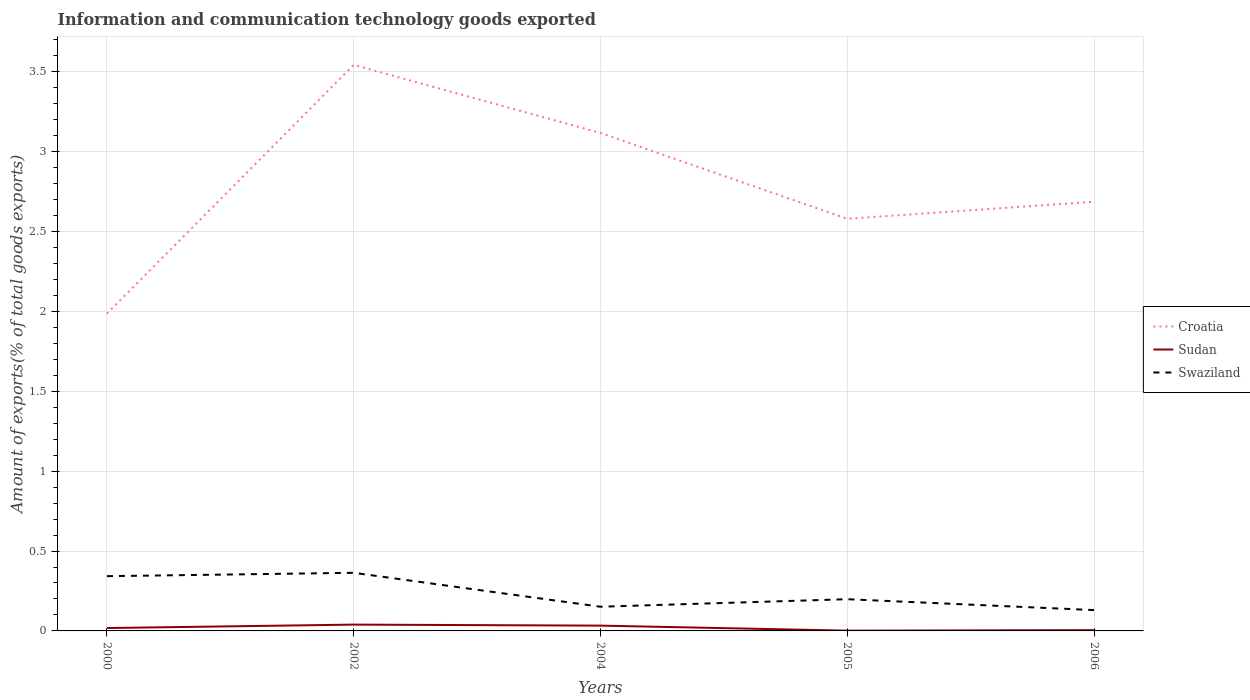How many different coloured lines are there?
Make the answer very short. 3. Is the number of lines equal to the number of legend labels?
Keep it short and to the point. Yes. Across all years, what is the maximum amount of goods exported in Swaziland?
Your answer should be compact. 0.13. In which year was the amount of goods exported in Swaziland maximum?
Offer a terse response. 2006. What is the total amount of goods exported in Swaziland in the graph?
Your answer should be compact. 0.07. What is the difference between the highest and the second highest amount of goods exported in Sudan?
Ensure brevity in your answer.  0.04. What is the difference between the highest and the lowest amount of goods exported in Sudan?
Provide a short and direct response. 2. Is the amount of goods exported in Swaziland strictly greater than the amount of goods exported in Sudan over the years?
Offer a terse response. No. How many lines are there?
Offer a very short reply. 3. Are the values on the major ticks of Y-axis written in scientific E-notation?
Offer a very short reply. No. Does the graph contain any zero values?
Ensure brevity in your answer.  No. Where does the legend appear in the graph?
Offer a very short reply. Center right. How many legend labels are there?
Offer a terse response. 3. How are the legend labels stacked?
Your answer should be very brief. Vertical. What is the title of the graph?
Make the answer very short. Information and communication technology goods exported. What is the label or title of the X-axis?
Make the answer very short. Years. What is the label or title of the Y-axis?
Ensure brevity in your answer.  Amount of exports(% of total goods exports). What is the Amount of exports(% of total goods exports) in Croatia in 2000?
Your answer should be compact. 1.99. What is the Amount of exports(% of total goods exports) in Sudan in 2000?
Offer a very short reply. 0.02. What is the Amount of exports(% of total goods exports) in Swaziland in 2000?
Give a very brief answer. 0.34. What is the Amount of exports(% of total goods exports) of Croatia in 2002?
Your response must be concise. 3.54. What is the Amount of exports(% of total goods exports) of Sudan in 2002?
Make the answer very short. 0.04. What is the Amount of exports(% of total goods exports) of Swaziland in 2002?
Your answer should be very brief. 0.36. What is the Amount of exports(% of total goods exports) in Croatia in 2004?
Offer a terse response. 3.12. What is the Amount of exports(% of total goods exports) of Sudan in 2004?
Give a very brief answer. 0.03. What is the Amount of exports(% of total goods exports) in Swaziland in 2004?
Offer a terse response. 0.15. What is the Amount of exports(% of total goods exports) in Croatia in 2005?
Your response must be concise. 2.58. What is the Amount of exports(% of total goods exports) in Sudan in 2005?
Ensure brevity in your answer.  0. What is the Amount of exports(% of total goods exports) of Swaziland in 2005?
Keep it short and to the point. 0.2. What is the Amount of exports(% of total goods exports) in Croatia in 2006?
Make the answer very short. 2.69. What is the Amount of exports(% of total goods exports) of Sudan in 2006?
Ensure brevity in your answer.  0. What is the Amount of exports(% of total goods exports) of Swaziland in 2006?
Offer a very short reply. 0.13. Across all years, what is the maximum Amount of exports(% of total goods exports) in Croatia?
Your answer should be compact. 3.54. Across all years, what is the maximum Amount of exports(% of total goods exports) of Sudan?
Give a very brief answer. 0.04. Across all years, what is the maximum Amount of exports(% of total goods exports) in Swaziland?
Your response must be concise. 0.36. Across all years, what is the minimum Amount of exports(% of total goods exports) of Croatia?
Your answer should be very brief. 1.99. Across all years, what is the minimum Amount of exports(% of total goods exports) of Sudan?
Your response must be concise. 0. Across all years, what is the minimum Amount of exports(% of total goods exports) of Swaziland?
Provide a short and direct response. 0.13. What is the total Amount of exports(% of total goods exports) in Croatia in the graph?
Ensure brevity in your answer.  13.91. What is the total Amount of exports(% of total goods exports) of Sudan in the graph?
Provide a succinct answer. 0.1. What is the total Amount of exports(% of total goods exports) in Swaziland in the graph?
Your answer should be compact. 1.19. What is the difference between the Amount of exports(% of total goods exports) in Croatia in 2000 and that in 2002?
Your answer should be compact. -1.56. What is the difference between the Amount of exports(% of total goods exports) in Sudan in 2000 and that in 2002?
Give a very brief answer. -0.02. What is the difference between the Amount of exports(% of total goods exports) of Swaziland in 2000 and that in 2002?
Your response must be concise. -0.02. What is the difference between the Amount of exports(% of total goods exports) in Croatia in 2000 and that in 2004?
Your answer should be very brief. -1.13. What is the difference between the Amount of exports(% of total goods exports) of Sudan in 2000 and that in 2004?
Your answer should be very brief. -0.02. What is the difference between the Amount of exports(% of total goods exports) of Swaziland in 2000 and that in 2004?
Make the answer very short. 0.19. What is the difference between the Amount of exports(% of total goods exports) in Croatia in 2000 and that in 2005?
Keep it short and to the point. -0.59. What is the difference between the Amount of exports(% of total goods exports) in Sudan in 2000 and that in 2005?
Offer a very short reply. 0.02. What is the difference between the Amount of exports(% of total goods exports) of Swaziland in 2000 and that in 2005?
Give a very brief answer. 0.14. What is the difference between the Amount of exports(% of total goods exports) in Croatia in 2000 and that in 2006?
Keep it short and to the point. -0.7. What is the difference between the Amount of exports(% of total goods exports) in Sudan in 2000 and that in 2006?
Keep it short and to the point. 0.01. What is the difference between the Amount of exports(% of total goods exports) of Swaziland in 2000 and that in 2006?
Make the answer very short. 0.21. What is the difference between the Amount of exports(% of total goods exports) in Croatia in 2002 and that in 2004?
Make the answer very short. 0.43. What is the difference between the Amount of exports(% of total goods exports) of Sudan in 2002 and that in 2004?
Give a very brief answer. 0.01. What is the difference between the Amount of exports(% of total goods exports) of Swaziland in 2002 and that in 2004?
Your answer should be very brief. 0.21. What is the difference between the Amount of exports(% of total goods exports) of Croatia in 2002 and that in 2005?
Your answer should be compact. 0.96. What is the difference between the Amount of exports(% of total goods exports) of Sudan in 2002 and that in 2005?
Your answer should be compact. 0.04. What is the difference between the Amount of exports(% of total goods exports) of Swaziland in 2002 and that in 2005?
Your response must be concise. 0.17. What is the difference between the Amount of exports(% of total goods exports) of Croatia in 2002 and that in 2006?
Your answer should be very brief. 0.86. What is the difference between the Amount of exports(% of total goods exports) in Sudan in 2002 and that in 2006?
Your answer should be compact. 0.03. What is the difference between the Amount of exports(% of total goods exports) of Swaziland in 2002 and that in 2006?
Make the answer very short. 0.23. What is the difference between the Amount of exports(% of total goods exports) in Croatia in 2004 and that in 2005?
Keep it short and to the point. 0.54. What is the difference between the Amount of exports(% of total goods exports) in Sudan in 2004 and that in 2005?
Provide a short and direct response. 0.03. What is the difference between the Amount of exports(% of total goods exports) in Swaziland in 2004 and that in 2005?
Provide a succinct answer. -0.05. What is the difference between the Amount of exports(% of total goods exports) in Croatia in 2004 and that in 2006?
Provide a short and direct response. 0.43. What is the difference between the Amount of exports(% of total goods exports) of Sudan in 2004 and that in 2006?
Your response must be concise. 0.03. What is the difference between the Amount of exports(% of total goods exports) in Swaziland in 2004 and that in 2006?
Provide a short and direct response. 0.02. What is the difference between the Amount of exports(% of total goods exports) in Croatia in 2005 and that in 2006?
Your answer should be compact. -0.11. What is the difference between the Amount of exports(% of total goods exports) of Sudan in 2005 and that in 2006?
Your answer should be compact. -0. What is the difference between the Amount of exports(% of total goods exports) in Swaziland in 2005 and that in 2006?
Provide a short and direct response. 0.07. What is the difference between the Amount of exports(% of total goods exports) in Croatia in 2000 and the Amount of exports(% of total goods exports) in Sudan in 2002?
Your answer should be compact. 1.95. What is the difference between the Amount of exports(% of total goods exports) of Croatia in 2000 and the Amount of exports(% of total goods exports) of Swaziland in 2002?
Provide a succinct answer. 1.62. What is the difference between the Amount of exports(% of total goods exports) of Sudan in 2000 and the Amount of exports(% of total goods exports) of Swaziland in 2002?
Provide a short and direct response. -0.35. What is the difference between the Amount of exports(% of total goods exports) in Croatia in 2000 and the Amount of exports(% of total goods exports) in Sudan in 2004?
Keep it short and to the point. 1.95. What is the difference between the Amount of exports(% of total goods exports) in Croatia in 2000 and the Amount of exports(% of total goods exports) in Swaziland in 2004?
Make the answer very short. 1.83. What is the difference between the Amount of exports(% of total goods exports) of Sudan in 2000 and the Amount of exports(% of total goods exports) of Swaziland in 2004?
Provide a succinct answer. -0.13. What is the difference between the Amount of exports(% of total goods exports) of Croatia in 2000 and the Amount of exports(% of total goods exports) of Sudan in 2005?
Provide a short and direct response. 1.98. What is the difference between the Amount of exports(% of total goods exports) in Croatia in 2000 and the Amount of exports(% of total goods exports) in Swaziland in 2005?
Provide a short and direct response. 1.79. What is the difference between the Amount of exports(% of total goods exports) in Sudan in 2000 and the Amount of exports(% of total goods exports) in Swaziland in 2005?
Your response must be concise. -0.18. What is the difference between the Amount of exports(% of total goods exports) in Croatia in 2000 and the Amount of exports(% of total goods exports) in Sudan in 2006?
Provide a short and direct response. 1.98. What is the difference between the Amount of exports(% of total goods exports) in Croatia in 2000 and the Amount of exports(% of total goods exports) in Swaziland in 2006?
Provide a short and direct response. 1.86. What is the difference between the Amount of exports(% of total goods exports) of Sudan in 2000 and the Amount of exports(% of total goods exports) of Swaziland in 2006?
Provide a succinct answer. -0.11. What is the difference between the Amount of exports(% of total goods exports) in Croatia in 2002 and the Amount of exports(% of total goods exports) in Sudan in 2004?
Provide a succinct answer. 3.51. What is the difference between the Amount of exports(% of total goods exports) in Croatia in 2002 and the Amount of exports(% of total goods exports) in Swaziland in 2004?
Your answer should be very brief. 3.39. What is the difference between the Amount of exports(% of total goods exports) in Sudan in 2002 and the Amount of exports(% of total goods exports) in Swaziland in 2004?
Provide a succinct answer. -0.11. What is the difference between the Amount of exports(% of total goods exports) in Croatia in 2002 and the Amount of exports(% of total goods exports) in Sudan in 2005?
Make the answer very short. 3.54. What is the difference between the Amount of exports(% of total goods exports) in Croatia in 2002 and the Amount of exports(% of total goods exports) in Swaziland in 2005?
Make the answer very short. 3.34. What is the difference between the Amount of exports(% of total goods exports) in Sudan in 2002 and the Amount of exports(% of total goods exports) in Swaziland in 2005?
Keep it short and to the point. -0.16. What is the difference between the Amount of exports(% of total goods exports) in Croatia in 2002 and the Amount of exports(% of total goods exports) in Sudan in 2006?
Your response must be concise. 3.54. What is the difference between the Amount of exports(% of total goods exports) in Croatia in 2002 and the Amount of exports(% of total goods exports) in Swaziland in 2006?
Your answer should be compact. 3.41. What is the difference between the Amount of exports(% of total goods exports) in Sudan in 2002 and the Amount of exports(% of total goods exports) in Swaziland in 2006?
Your answer should be compact. -0.09. What is the difference between the Amount of exports(% of total goods exports) of Croatia in 2004 and the Amount of exports(% of total goods exports) of Sudan in 2005?
Your response must be concise. 3.12. What is the difference between the Amount of exports(% of total goods exports) of Croatia in 2004 and the Amount of exports(% of total goods exports) of Swaziland in 2005?
Keep it short and to the point. 2.92. What is the difference between the Amount of exports(% of total goods exports) in Sudan in 2004 and the Amount of exports(% of total goods exports) in Swaziland in 2005?
Offer a very short reply. -0.17. What is the difference between the Amount of exports(% of total goods exports) in Croatia in 2004 and the Amount of exports(% of total goods exports) in Sudan in 2006?
Give a very brief answer. 3.11. What is the difference between the Amount of exports(% of total goods exports) of Croatia in 2004 and the Amount of exports(% of total goods exports) of Swaziland in 2006?
Offer a very short reply. 2.99. What is the difference between the Amount of exports(% of total goods exports) in Sudan in 2004 and the Amount of exports(% of total goods exports) in Swaziland in 2006?
Offer a very short reply. -0.1. What is the difference between the Amount of exports(% of total goods exports) of Croatia in 2005 and the Amount of exports(% of total goods exports) of Sudan in 2006?
Provide a short and direct response. 2.57. What is the difference between the Amount of exports(% of total goods exports) of Croatia in 2005 and the Amount of exports(% of total goods exports) of Swaziland in 2006?
Your response must be concise. 2.45. What is the difference between the Amount of exports(% of total goods exports) in Sudan in 2005 and the Amount of exports(% of total goods exports) in Swaziland in 2006?
Keep it short and to the point. -0.13. What is the average Amount of exports(% of total goods exports) in Croatia per year?
Your answer should be compact. 2.78. What is the average Amount of exports(% of total goods exports) of Sudan per year?
Give a very brief answer. 0.02. What is the average Amount of exports(% of total goods exports) in Swaziland per year?
Give a very brief answer. 0.24. In the year 2000, what is the difference between the Amount of exports(% of total goods exports) in Croatia and Amount of exports(% of total goods exports) in Sudan?
Ensure brevity in your answer.  1.97. In the year 2000, what is the difference between the Amount of exports(% of total goods exports) of Croatia and Amount of exports(% of total goods exports) of Swaziland?
Make the answer very short. 1.64. In the year 2000, what is the difference between the Amount of exports(% of total goods exports) of Sudan and Amount of exports(% of total goods exports) of Swaziland?
Keep it short and to the point. -0.32. In the year 2002, what is the difference between the Amount of exports(% of total goods exports) of Croatia and Amount of exports(% of total goods exports) of Sudan?
Provide a succinct answer. 3.5. In the year 2002, what is the difference between the Amount of exports(% of total goods exports) of Croatia and Amount of exports(% of total goods exports) of Swaziland?
Ensure brevity in your answer.  3.18. In the year 2002, what is the difference between the Amount of exports(% of total goods exports) of Sudan and Amount of exports(% of total goods exports) of Swaziland?
Ensure brevity in your answer.  -0.32. In the year 2004, what is the difference between the Amount of exports(% of total goods exports) in Croatia and Amount of exports(% of total goods exports) in Sudan?
Provide a succinct answer. 3.08. In the year 2004, what is the difference between the Amount of exports(% of total goods exports) of Croatia and Amount of exports(% of total goods exports) of Swaziland?
Ensure brevity in your answer.  2.97. In the year 2004, what is the difference between the Amount of exports(% of total goods exports) of Sudan and Amount of exports(% of total goods exports) of Swaziland?
Offer a terse response. -0.12. In the year 2005, what is the difference between the Amount of exports(% of total goods exports) in Croatia and Amount of exports(% of total goods exports) in Sudan?
Give a very brief answer. 2.58. In the year 2005, what is the difference between the Amount of exports(% of total goods exports) of Croatia and Amount of exports(% of total goods exports) of Swaziland?
Give a very brief answer. 2.38. In the year 2005, what is the difference between the Amount of exports(% of total goods exports) of Sudan and Amount of exports(% of total goods exports) of Swaziland?
Offer a terse response. -0.2. In the year 2006, what is the difference between the Amount of exports(% of total goods exports) of Croatia and Amount of exports(% of total goods exports) of Sudan?
Offer a terse response. 2.68. In the year 2006, what is the difference between the Amount of exports(% of total goods exports) in Croatia and Amount of exports(% of total goods exports) in Swaziland?
Offer a terse response. 2.56. In the year 2006, what is the difference between the Amount of exports(% of total goods exports) of Sudan and Amount of exports(% of total goods exports) of Swaziland?
Provide a succinct answer. -0.13. What is the ratio of the Amount of exports(% of total goods exports) of Croatia in 2000 to that in 2002?
Make the answer very short. 0.56. What is the ratio of the Amount of exports(% of total goods exports) in Sudan in 2000 to that in 2002?
Your answer should be compact. 0.46. What is the ratio of the Amount of exports(% of total goods exports) of Swaziland in 2000 to that in 2002?
Your answer should be compact. 0.94. What is the ratio of the Amount of exports(% of total goods exports) in Croatia in 2000 to that in 2004?
Your answer should be compact. 0.64. What is the ratio of the Amount of exports(% of total goods exports) in Sudan in 2000 to that in 2004?
Provide a succinct answer. 0.54. What is the ratio of the Amount of exports(% of total goods exports) in Swaziland in 2000 to that in 2004?
Your answer should be compact. 2.26. What is the ratio of the Amount of exports(% of total goods exports) in Croatia in 2000 to that in 2005?
Provide a succinct answer. 0.77. What is the ratio of the Amount of exports(% of total goods exports) in Sudan in 2000 to that in 2005?
Provide a succinct answer. 10.29. What is the ratio of the Amount of exports(% of total goods exports) in Swaziland in 2000 to that in 2005?
Give a very brief answer. 1.73. What is the ratio of the Amount of exports(% of total goods exports) of Croatia in 2000 to that in 2006?
Provide a succinct answer. 0.74. What is the ratio of the Amount of exports(% of total goods exports) of Sudan in 2000 to that in 2006?
Your answer should be very brief. 3.62. What is the ratio of the Amount of exports(% of total goods exports) in Swaziland in 2000 to that in 2006?
Make the answer very short. 2.63. What is the ratio of the Amount of exports(% of total goods exports) in Croatia in 2002 to that in 2004?
Offer a terse response. 1.14. What is the ratio of the Amount of exports(% of total goods exports) of Sudan in 2002 to that in 2004?
Make the answer very short. 1.19. What is the ratio of the Amount of exports(% of total goods exports) in Swaziland in 2002 to that in 2004?
Provide a short and direct response. 2.4. What is the ratio of the Amount of exports(% of total goods exports) of Croatia in 2002 to that in 2005?
Give a very brief answer. 1.37. What is the ratio of the Amount of exports(% of total goods exports) of Sudan in 2002 to that in 2005?
Your answer should be very brief. 22.61. What is the ratio of the Amount of exports(% of total goods exports) of Swaziland in 2002 to that in 2005?
Your answer should be very brief. 1.83. What is the ratio of the Amount of exports(% of total goods exports) in Croatia in 2002 to that in 2006?
Your response must be concise. 1.32. What is the ratio of the Amount of exports(% of total goods exports) of Sudan in 2002 to that in 2006?
Your response must be concise. 7.96. What is the ratio of the Amount of exports(% of total goods exports) in Swaziland in 2002 to that in 2006?
Your answer should be compact. 2.79. What is the ratio of the Amount of exports(% of total goods exports) in Croatia in 2004 to that in 2005?
Your answer should be compact. 1.21. What is the ratio of the Amount of exports(% of total goods exports) of Sudan in 2004 to that in 2005?
Make the answer very short. 18.98. What is the ratio of the Amount of exports(% of total goods exports) of Swaziland in 2004 to that in 2005?
Offer a terse response. 0.76. What is the ratio of the Amount of exports(% of total goods exports) in Croatia in 2004 to that in 2006?
Your response must be concise. 1.16. What is the ratio of the Amount of exports(% of total goods exports) in Sudan in 2004 to that in 2006?
Ensure brevity in your answer.  6.68. What is the ratio of the Amount of exports(% of total goods exports) in Swaziland in 2004 to that in 2006?
Your answer should be very brief. 1.16. What is the ratio of the Amount of exports(% of total goods exports) of Croatia in 2005 to that in 2006?
Make the answer very short. 0.96. What is the ratio of the Amount of exports(% of total goods exports) in Sudan in 2005 to that in 2006?
Offer a very short reply. 0.35. What is the ratio of the Amount of exports(% of total goods exports) of Swaziland in 2005 to that in 2006?
Offer a very short reply. 1.52. What is the difference between the highest and the second highest Amount of exports(% of total goods exports) in Croatia?
Give a very brief answer. 0.43. What is the difference between the highest and the second highest Amount of exports(% of total goods exports) in Sudan?
Provide a short and direct response. 0.01. What is the difference between the highest and the second highest Amount of exports(% of total goods exports) of Swaziland?
Keep it short and to the point. 0.02. What is the difference between the highest and the lowest Amount of exports(% of total goods exports) of Croatia?
Your answer should be very brief. 1.56. What is the difference between the highest and the lowest Amount of exports(% of total goods exports) in Sudan?
Give a very brief answer. 0.04. What is the difference between the highest and the lowest Amount of exports(% of total goods exports) of Swaziland?
Keep it short and to the point. 0.23. 